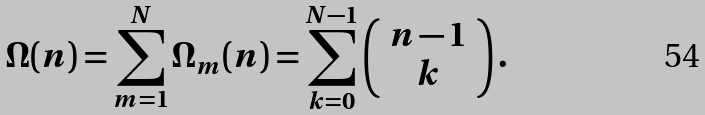Convert formula to latex. <formula><loc_0><loc_0><loc_500><loc_500>\Omega ( n ) = \sum _ { m = 1 } ^ { N } \Omega _ { m } ( n ) = \sum _ { k = 0 } ^ { N - 1 } \left ( \begin{array} { c c } n - 1 \\ k \end{array} \right ) .</formula> 